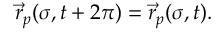<formula> <loc_0><loc_0><loc_500><loc_500>\vec { r } _ { p } ( \sigma , t + 2 \pi ) = \vec { r } _ { p } ( \sigma , t ) .</formula> 